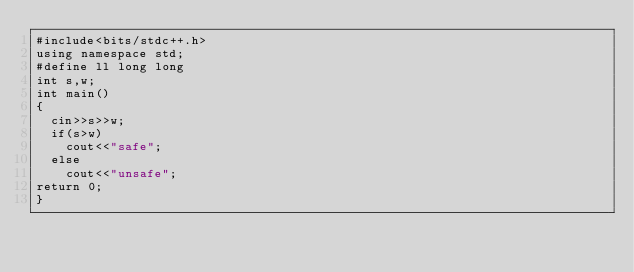Convert code to text. <code><loc_0><loc_0><loc_500><loc_500><_C++_>#include<bits/stdc++.h>
using namespace std;
#define ll long long
int s,w;
int main()
{
	cin>>s>>w;
	if(s>w)
		cout<<"safe";
	else
		cout<<"unsafe";
return 0;
}
</code> 